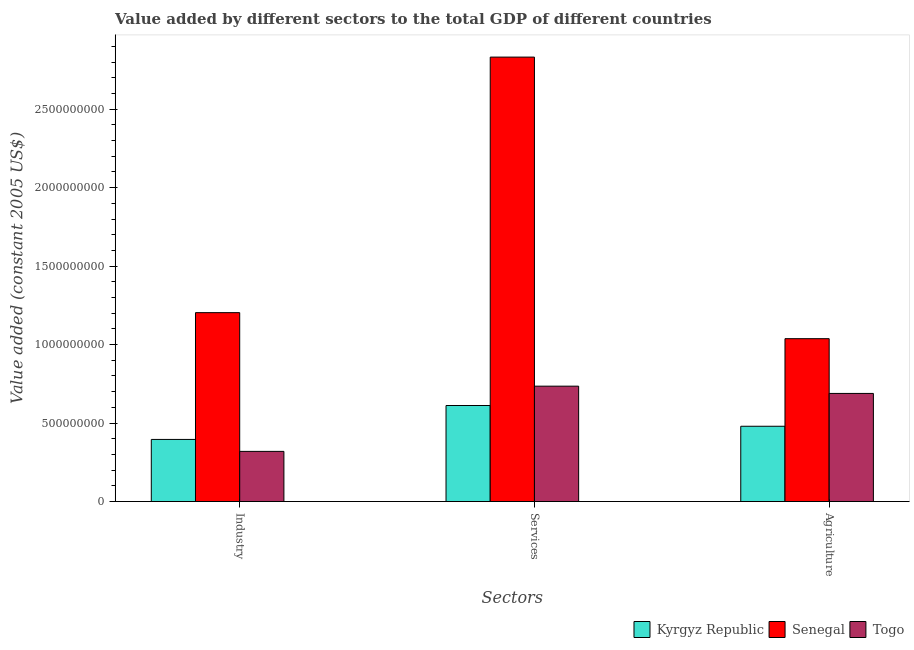How many different coloured bars are there?
Offer a very short reply. 3. Are the number of bars per tick equal to the number of legend labels?
Provide a succinct answer. Yes. What is the label of the 1st group of bars from the left?
Offer a terse response. Industry. What is the value added by agricultural sector in Kyrgyz Republic?
Offer a very short reply. 4.80e+08. Across all countries, what is the maximum value added by industrial sector?
Make the answer very short. 1.20e+09. Across all countries, what is the minimum value added by agricultural sector?
Ensure brevity in your answer.  4.80e+08. In which country was the value added by services maximum?
Make the answer very short. Senegal. In which country was the value added by services minimum?
Offer a very short reply. Kyrgyz Republic. What is the total value added by agricultural sector in the graph?
Your answer should be compact. 2.21e+09. What is the difference between the value added by agricultural sector in Kyrgyz Republic and that in Togo?
Offer a very short reply. -2.09e+08. What is the difference between the value added by services in Kyrgyz Republic and the value added by agricultural sector in Senegal?
Your response must be concise. -4.26e+08. What is the average value added by agricultural sector per country?
Provide a short and direct response. 7.35e+08. What is the difference between the value added by services and value added by industrial sector in Senegal?
Offer a very short reply. 1.63e+09. What is the ratio of the value added by agricultural sector in Togo to that in Kyrgyz Republic?
Provide a short and direct response. 1.44. Is the value added by services in Kyrgyz Republic less than that in Senegal?
Keep it short and to the point. Yes. Is the difference between the value added by services in Senegal and Kyrgyz Republic greater than the difference between the value added by agricultural sector in Senegal and Kyrgyz Republic?
Your response must be concise. Yes. What is the difference between the highest and the second highest value added by industrial sector?
Give a very brief answer. 8.08e+08. What is the difference between the highest and the lowest value added by agricultural sector?
Provide a succinct answer. 5.58e+08. In how many countries, is the value added by agricultural sector greater than the average value added by agricultural sector taken over all countries?
Your answer should be compact. 1. Is the sum of the value added by industrial sector in Senegal and Togo greater than the maximum value added by services across all countries?
Offer a very short reply. No. What does the 2nd bar from the left in Industry represents?
Keep it short and to the point. Senegal. What does the 1st bar from the right in Services represents?
Provide a short and direct response. Togo. Is it the case that in every country, the sum of the value added by industrial sector and value added by services is greater than the value added by agricultural sector?
Give a very brief answer. Yes. Are all the bars in the graph horizontal?
Offer a very short reply. No. Does the graph contain grids?
Your response must be concise. No. Where does the legend appear in the graph?
Your answer should be compact. Bottom right. How many legend labels are there?
Your response must be concise. 3. What is the title of the graph?
Provide a short and direct response. Value added by different sectors to the total GDP of different countries. Does "Djibouti" appear as one of the legend labels in the graph?
Make the answer very short. No. What is the label or title of the X-axis?
Ensure brevity in your answer.  Sectors. What is the label or title of the Y-axis?
Give a very brief answer. Value added (constant 2005 US$). What is the Value added (constant 2005 US$) in Kyrgyz Republic in Industry?
Offer a terse response. 3.96e+08. What is the Value added (constant 2005 US$) in Senegal in Industry?
Your response must be concise. 1.20e+09. What is the Value added (constant 2005 US$) of Togo in Industry?
Provide a succinct answer. 3.20e+08. What is the Value added (constant 2005 US$) in Kyrgyz Republic in Services?
Provide a short and direct response. 6.12e+08. What is the Value added (constant 2005 US$) in Senegal in Services?
Your answer should be compact. 2.83e+09. What is the Value added (constant 2005 US$) of Togo in Services?
Keep it short and to the point. 7.35e+08. What is the Value added (constant 2005 US$) in Kyrgyz Republic in Agriculture?
Your answer should be compact. 4.80e+08. What is the Value added (constant 2005 US$) in Senegal in Agriculture?
Keep it short and to the point. 1.04e+09. What is the Value added (constant 2005 US$) in Togo in Agriculture?
Your answer should be compact. 6.89e+08. Across all Sectors, what is the maximum Value added (constant 2005 US$) in Kyrgyz Republic?
Offer a terse response. 6.12e+08. Across all Sectors, what is the maximum Value added (constant 2005 US$) of Senegal?
Your answer should be very brief. 2.83e+09. Across all Sectors, what is the maximum Value added (constant 2005 US$) of Togo?
Make the answer very short. 7.35e+08. Across all Sectors, what is the minimum Value added (constant 2005 US$) in Kyrgyz Republic?
Offer a very short reply. 3.96e+08. Across all Sectors, what is the minimum Value added (constant 2005 US$) in Senegal?
Make the answer very short. 1.04e+09. Across all Sectors, what is the minimum Value added (constant 2005 US$) in Togo?
Keep it short and to the point. 3.20e+08. What is the total Value added (constant 2005 US$) in Kyrgyz Republic in the graph?
Offer a very short reply. 1.49e+09. What is the total Value added (constant 2005 US$) in Senegal in the graph?
Your answer should be very brief. 5.07e+09. What is the total Value added (constant 2005 US$) in Togo in the graph?
Keep it short and to the point. 1.74e+09. What is the difference between the Value added (constant 2005 US$) in Kyrgyz Republic in Industry and that in Services?
Provide a succinct answer. -2.16e+08. What is the difference between the Value added (constant 2005 US$) in Senegal in Industry and that in Services?
Your response must be concise. -1.63e+09. What is the difference between the Value added (constant 2005 US$) of Togo in Industry and that in Services?
Provide a short and direct response. -4.16e+08. What is the difference between the Value added (constant 2005 US$) in Kyrgyz Republic in Industry and that in Agriculture?
Make the answer very short. -8.39e+07. What is the difference between the Value added (constant 2005 US$) in Senegal in Industry and that in Agriculture?
Provide a short and direct response. 1.66e+08. What is the difference between the Value added (constant 2005 US$) of Togo in Industry and that in Agriculture?
Ensure brevity in your answer.  -3.69e+08. What is the difference between the Value added (constant 2005 US$) of Kyrgyz Republic in Services and that in Agriculture?
Provide a succinct answer. 1.32e+08. What is the difference between the Value added (constant 2005 US$) of Senegal in Services and that in Agriculture?
Give a very brief answer. 1.79e+09. What is the difference between the Value added (constant 2005 US$) of Togo in Services and that in Agriculture?
Your answer should be compact. 4.63e+07. What is the difference between the Value added (constant 2005 US$) in Kyrgyz Republic in Industry and the Value added (constant 2005 US$) in Senegal in Services?
Offer a terse response. -2.44e+09. What is the difference between the Value added (constant 2005 US$) in Kyrgyz Republic in Industry and the Value added (constant 2005 US$) in Togo in Services?
Provide a succinct answer. -3.39e+08. What is the difference between the Value added (constant 2005 US$) of Senegal in Industry and the Value added (constant 2005 US$) of Togo in Services?
Your answer should be compact. 4.68e+08. What is the difference between the Value added (constant 2005 US$) in Kyrgyz Republic in Industry and the Value added (constant 2005 US$) in Senegal in Agriculture?
Offer a terse response. -6.42e+08. What is the difference between the Value added (constant 2005 US$) in Kyrgyz Republic in Industry and the Value added (constant 2005 US$) in Togo in Agriculture?
Offer a terse response. -2.93e+08. What is the difference between the Value added (constant 2005 US$) of Senegal in Industry and the Value added (constant 2005 US$) of Togo in Agriculture?
Ensure brevity in your answer.  5.15e+08. What is the difference between the Value added (constant 2005 US$) in Kyrgyz Republic in Services and the Value added (constant 2005 US$) in Senegal in Agriculture?
Keep it short and to the point. -4.26e+08. What is the difference between the Value added (constant 2005 US$) of Kyrgyz Republic in Services and the Value added (constant 2005 US$) of Togo in Agriculture?
Keep it short and to the point. -7.69e+07. What is the difference between the Value added (constant 2005 US$) of Senegal in Services and the Value added (constant 2005 US$) of Togo in Agriculture?
Provide a succinct answer. 2.14e+09. What is the average Value added (constant 2005 US$) of Kyrgyz Republic per Sectors?
Keep it short and to the point. 4.96e+08. What is the average Value added (constant 2005 US$) in Senegal per Sectors?
Keep it short and to the point. 1.69e+09. What is the average Value added (constant 2005 US$) of Togo per Sectors?
Your response must be concise. 5.81e+08. What is the difference between the Value added (constant 2005 US$) of Kyrgyz Republic and Value added (constant 2005 US$) of Senegal in Industry?
Your answer should be very brief. -8.08e+08. What is the difference between the Value added (constant 2005 US$) in Kyrgyz Republic and Value added (constant 2005 US$) in Togo in Industry?
Your answer should be very brief. 7.62e+07. What is the difference between the Value added (constant 2005 US$) of Senegal and Value added (constant 2005 US$) of Togo in Industry?
Keep it short and to the point. 8.84e+08. What is the difference between the Value added (constant 2005 US$) in Kyrgyz Republic and Value added (constant 2005 US$) in Senegal in Services?
Provide a short and direct response. -2.22e+09. What is the difference between the Value added (constant 2005 US$) in Kyrgyz Republic and Value added (constant 2005 US$) in Togo in Services?
Give a very brief answer. -1.23e+08. What is the difference between the Value added (constant 2005 US$) of Senegal and Value added (constant 2005 US$) of Togo in Services?
Provide a succinct answer. 2.10e+09. What is the difference between the Value added (constant 2005 US$) of Kyrgyz Republic and Value added (constant 2005 US$) of Senegal in Agriculture?
Offer a very short reply. -5.58e+08. What is the difference between the Value added (constant 2005 US$) of Kyrgyz Republic and Value added (constant 2005 US$) of Togo in Agriculture?
Make the answer very short. -2.09e+08. What is the difference between the Value added (constant 2005 US$) of Senegal and Value added (constant 2005 US$) of Togo in Agriculture?
Make the answer very short. 3.49e+08. What is the ratio of the Value added (constant 2005 US$) of Kyrgyz Republic in Industry to that in Services?
Give a very brief answer. 0.65. What is the ratio of the Value added (constant 2005 US$) in Senegal in Industry to that in Services?
Offer a very short reply. 0.42. What is the ratio of the Value added (constant 2005 US$) in Togo in Industry to that in Services?
Offer a very short reply. 0.43. What is the ratio of the Value added (constant 2005 US$) in Kyrgyz Republic in Industry to that in Agriculture?
Your response must be concise. 0.83. What is the ratio of the Value added (constant 2005 US$) in Senegal in Industry to that in Agriculture?
Give a very brief answer. 1.16. What is the ratio of the Value added (constant 2005 US$) of Togo in Industry to that in Agriculture?
Give a very brief answer. 0.46. What is the ratio of the Value added (constant 2005 US$) in Kyrgyz Republic in Services to that in Agriculture?
Your response must be concise. 1.28. What is the ratio of the Value added (constant 2005 US$) in Senegal in Services to that in Agriculture?
Make the answer very short. 2.73. What is the ratio of the Value added (constant 2005 US$) of Togo in Services to that in Agriculture?
Keep it short and to the point. 1.07. What is the difference between the highest and the second highest Value added (constant 2005 US$) in Kyrgyz Republic?
Offer a very short reply. 1.32e+08. What is the difference between the highest and the second highest Value added (constant 2005 US$) of Senegal?
Give a very brief answer. 1.63e+09. What is the difference between the highest and the second highest Value added (constant 2005 US$) of Togo?
Your answer should be compact. 4.63e+07. What is the difference between the highest and the lowest Value added (constant 2005 US$) of Kyrgyz Republic?
Give a very brief answer. 2.16e+08. What is the difference between the highest and the lowest Value added (constant 2005 US$) of Senegal?
Give a very brief answer. 1.79e+09. What is the difference between the highest and the lowest Value added (constant 2005 US$) in Togo?
Offer a very short reply. 4.16e+08. 